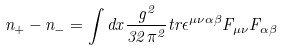<formula> <loc_0><loc_0><loc_500><loc_500>n _ { + } - n _ { - } = \int d x \frac { g ^ { 2 } } { 3 2 \pi ^ { 2 } } t r \epsilon ^ { \mu \nu \alpha \beta } F _ { \mu \nu } F _ { \alpha \beta }</formula> 